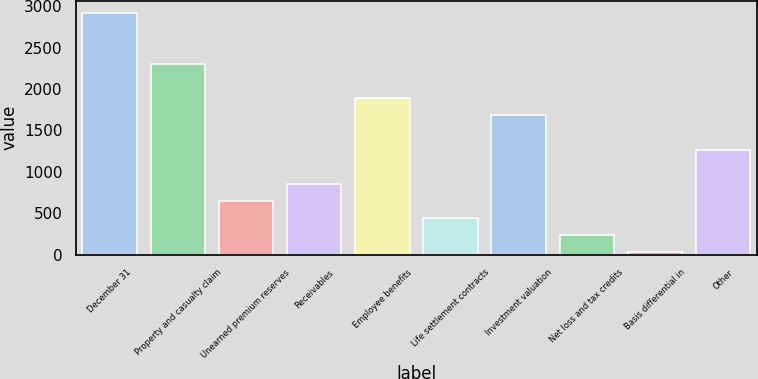<chart> <loc_0><loc_0><loc_500><loc_500><bar_chart><fcel>December 31<fcel>Property and casualty claim<fcel>Unearned premium reserves<fcel>Receivables<fcel>Employee benefits<fcel>Life settlement contracts<fcel>Investment valuation<fcel>Net loss and tax credits<fcel>Basis differential in<fcel>Other<nl><fcel>2918.8<fcel>2300.2<fcel>650.6<fcel>856.8<fcel>1887.8<fcel>444.4<fcel>1681.6<fcel>238.2<fcel>32<fcel>1269.2<nl></chart> 